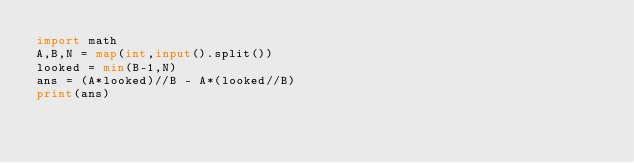Convert code to text. <code><loc_0><loc_0><loc_500><loc_500><_Python_>import math
A,B,N = map(int,input().split())
looked = min(B-1,N)
ans = (A*looked)//B - A*(looked//B)
print(ans)</code> 